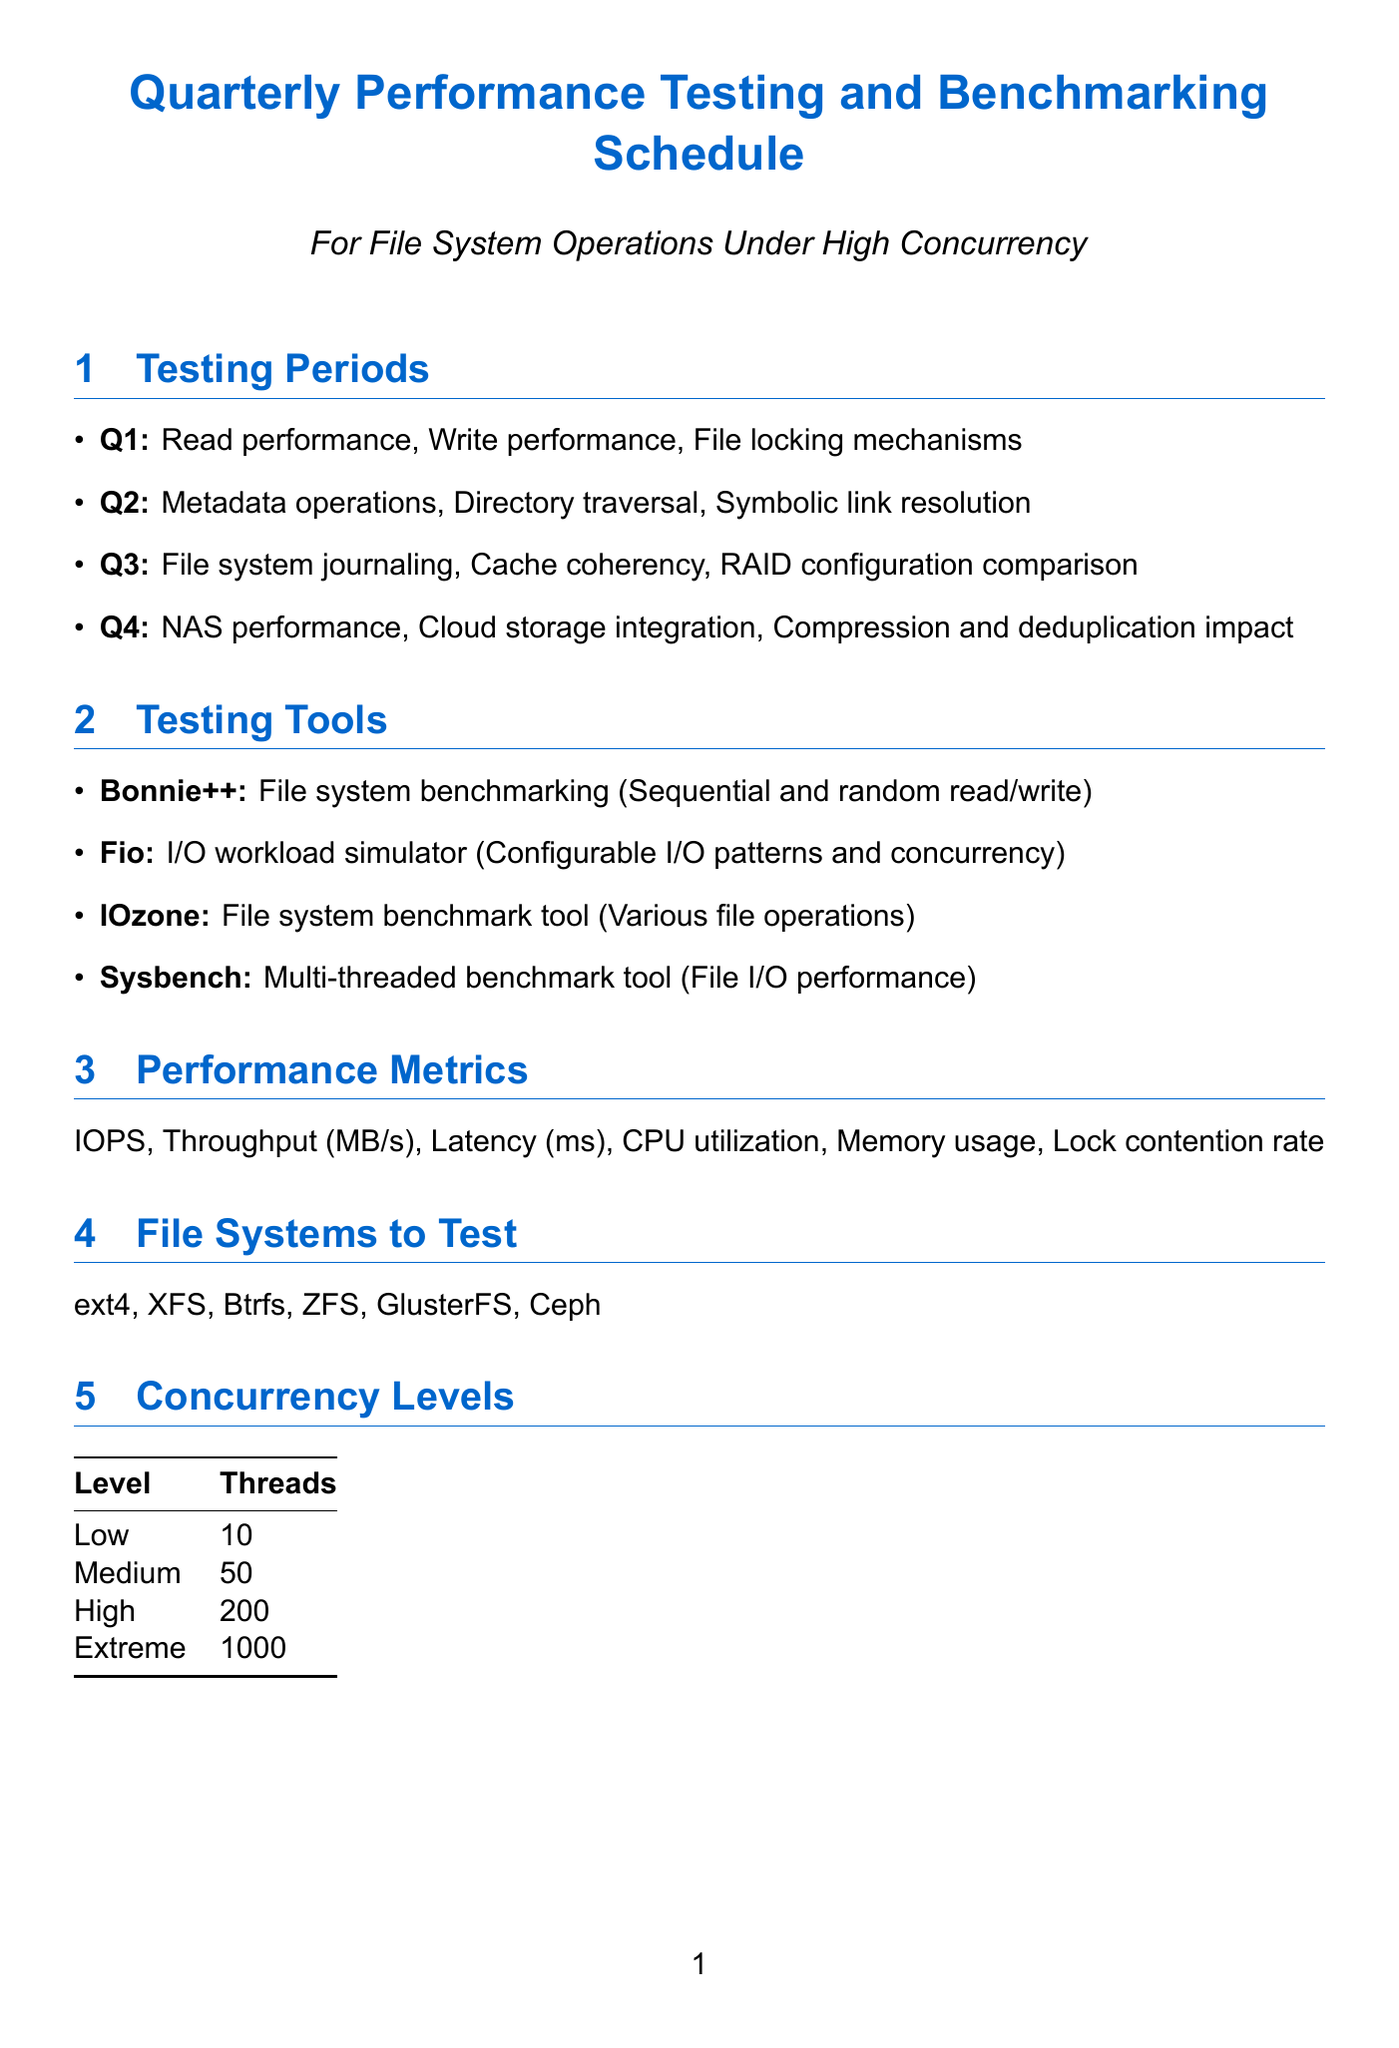What are the focus areas for Q2? The focus areas for Q2 include metadata operations performance, directory traversal speed, and symbolic link resolution time.
Answer: Metadata operations, directory traversal, symbolic link resolution How many threads are used for high concurrency? The document states that high concurrency level uses 200 threads.
Answer: 200 What tool is used for file system benchmarking? Bonnie++ is identified as the tool used for file system benchmarking in the document.
Answer: Bonnie++ What is the frequency of stakeholder meetings? The frequency of stakeholder meetings is stated as bi-weekly in the document.
Answer: Bi-weekly Which performance metric involves measuring Input/Output operations? IOPS is the performance metric that involves measuring Input/Output operations per second.
Answer: IOPS What are the small file characteristics in the test dataset? The document describes small files as consisting of 1,000,000 files, each 4KB in size.
Answer: 1,000,000 files, 4KB each How many levels of concurrency are mentioned? There are four levels of concurrency mentioned in the document.
Answer: Four What is the purpose of the Fio tool? The purpose of the Fio tool is to simulate I/O workloads with configurable I/O patterns and concurrency levels.
Answer: Configurable I/O patterns and concurrency levels What file systems are included for testing? The file systems included for testing are ext4, XFS, Btrfs, ZFS, GlusterFS, and Ceph.
Answer: ext4, XFS, Btrfs, ZFS, GlusterFS, Ceph 